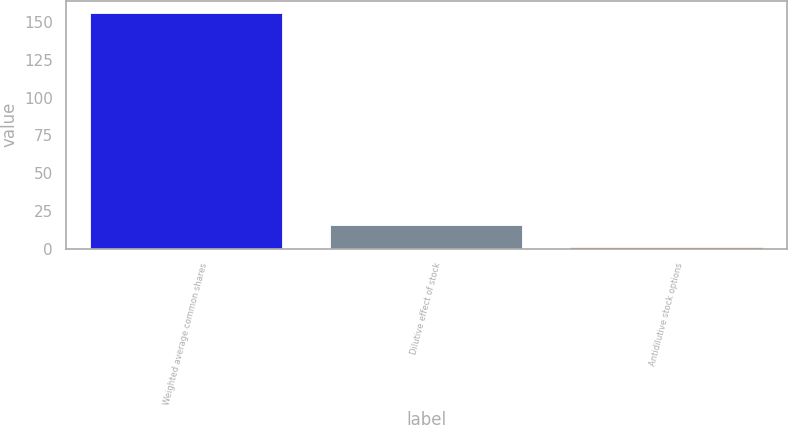<chart> <loc_0><loc_0><loc_500><loc_500><bar_chart><fcel>Weighted average common shares<fcel>Dilutive effect of stock<fcel>Antidilutive stock options<nl><fcel>156.32<fcel>15.52<fcel>1.2<nl></chart> 